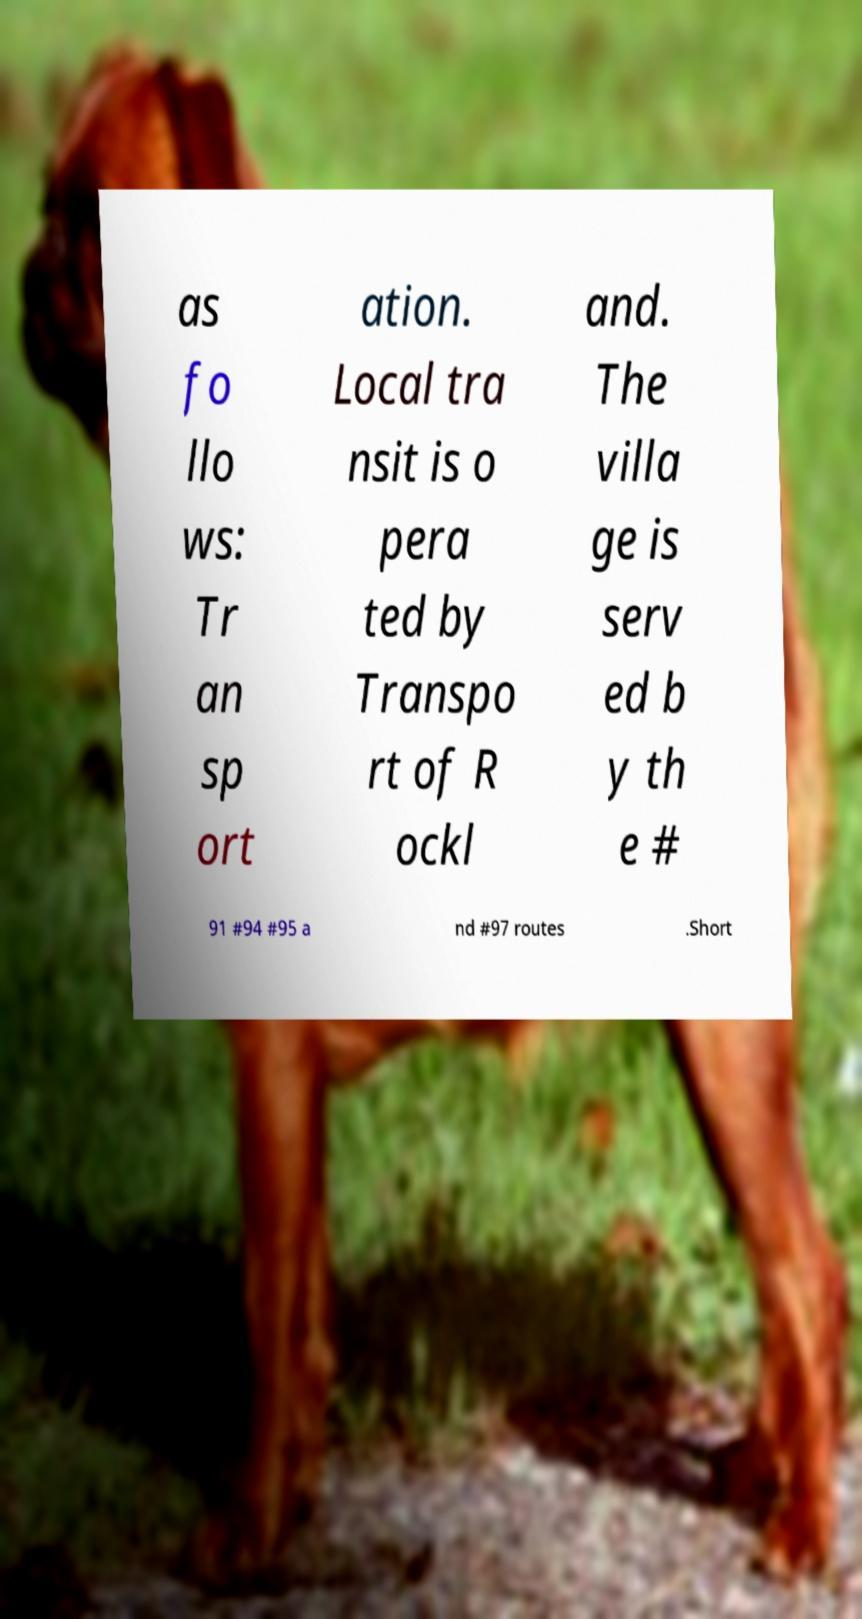What messages or text are displayed in this image? I need them in a readable, typed format. as fo llo ws: Tr an sp ort ation. Local tra nsit is o pera ted by Transpo rt of R ockl and. The villa ge is serv ed b y th e # 91 #94 #95 a nd #97 routes .Short 